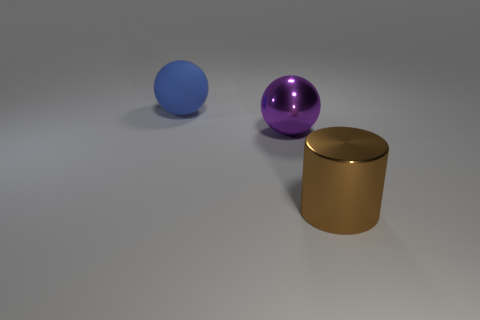How many cubes are either tiny green metallic things or big purple things?
Your response must be concise. 0. What number of things are both behind the big metal cylinder and in front of the matte thing?
Ensure brevity in your answer.  1. There is a shiny object on the left side of the big brown thing; what is its color?
Keep it short and to the point. Purple. There is a brown object that is the same material as the large purple ball; what is its size?
Offer a very short reply. Large. What number of large matte spheres are in front of the large metal thing behind the metallic cylinder?
Provide a succinct answer. 0. What number of blue spheres are behind the big blue ball?
Your answer should be very brief. 0. The large ball that is in front of the big blue matte object that is on the left side of the metal object behind the big brown metallic object is what color?
Give a very brief answer. Purple. There is a metal object that is to the left of the large brown shiny cylinder; is its color the same as the metallic object that is in front of the big purple ball?
Offer a terse response. No. What is the shape of the object that is right of the shiny thing that is to the left of the big brown metal thing?
Your answer should be very brief. Cylinder. Is there a red metallic sphere of the same size as the cylinder?
Provide a short and direct response. No. 